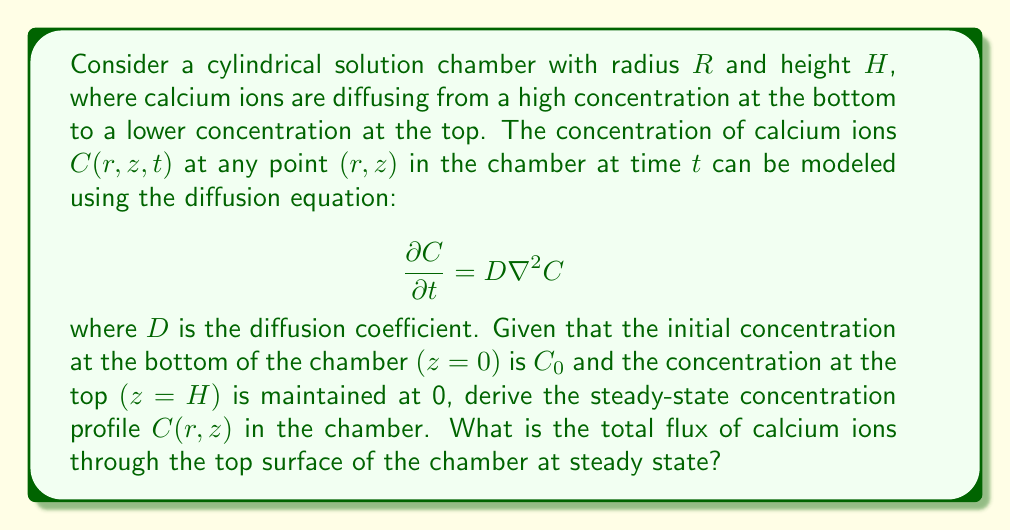Help me with this question. To solve this problem, we'll follow these steps:

1) First, we need to set up the steady-state diffusion equation. At steady state, $\frac{\partial C}{\partial t} = 0$, so our equation becomes:

   $$\nabla^2 C = 0$$

2) In cylindrical coordinates, the Laplacian is:

   $$\nabla^2 C = \frac{1}{r}\frac{\partial}{\partial r}\left(r\frac{\partial C}{\partial r}\right) + \frac{1}{r^2}\frac{\partial^2 C}{\partial \theta^2} + \frac{\partial^2 C}{\partial z^2}$$

3) Due to the symmetry of our problem, there's no dependence on $\theta$, so $\frac{\partial^2 C}{\partial \theta^2} = 0$. Our equation simplifies to:

   $$\frac{1}{r}\frac{\partial}{\partial r}\left(r\frac{\partial C}{\partial r}\right) + \frac{\partial^2 C}{\partial z^2} = 0$$

4) The boundary conditions are:
   - $C(r, 0) = C_0$ (concentration at bottom)
   - $C(r, H) = 0$ (concentration at top)
   - $\frac{\partial C}{\partial r}|_{r=R} = 0$ (no flux through side walls)

5) Given these conditions, we can assume that the concentration only depends on $z$. So $\frac{\partial C}{\partial r} = 0$, and our equation further simplifies to:

   $$\frac{d^2 C}{dz^2} = 0$$

6) The general solution to this equation is:

   $$C(z) = Az + B$$

7) Applying the boundary conditions:
   - At $z = 0$: $C_0 = B$
   - At $z = H$: $0 = AH + C_0$

8) Solving these, we get:
   $$A = -\frac{C_0}{H}, B = C_0$$

9) Therefore, the steady-state concentration profile is:

   $$C(z) = C_0\left(1 - \frac{z}{H}\right)$$

10) To find the total flux through the top surface, we use Fick's first law:

    $$J = -D\frac{dC}{dz}$$

11) At $z = H$:

    $$J = -D\frac{d}{dz}\left[C_0\left(1 - \frac{z}{H}\right)\right] = D\frac{C_0}{H}$$

12) The total flux through the top surface is this flux multiplied by the area of the top surface:

    $$\text{Total Flux} = J \cdot \pi R^2 = D\frac{C_0}{H} \cdot \pi R^2$$
Answer: The steady-state concentration profile is:

$$C(z) = C_0\left(1 - \frac{z}{H}\right)$$

The total flux of calcium ions through the top surface of the chamber at steady state is:

$$\text{Total Flux} = D\frac{C_0}{H} \cdot \pi R^2$$ 